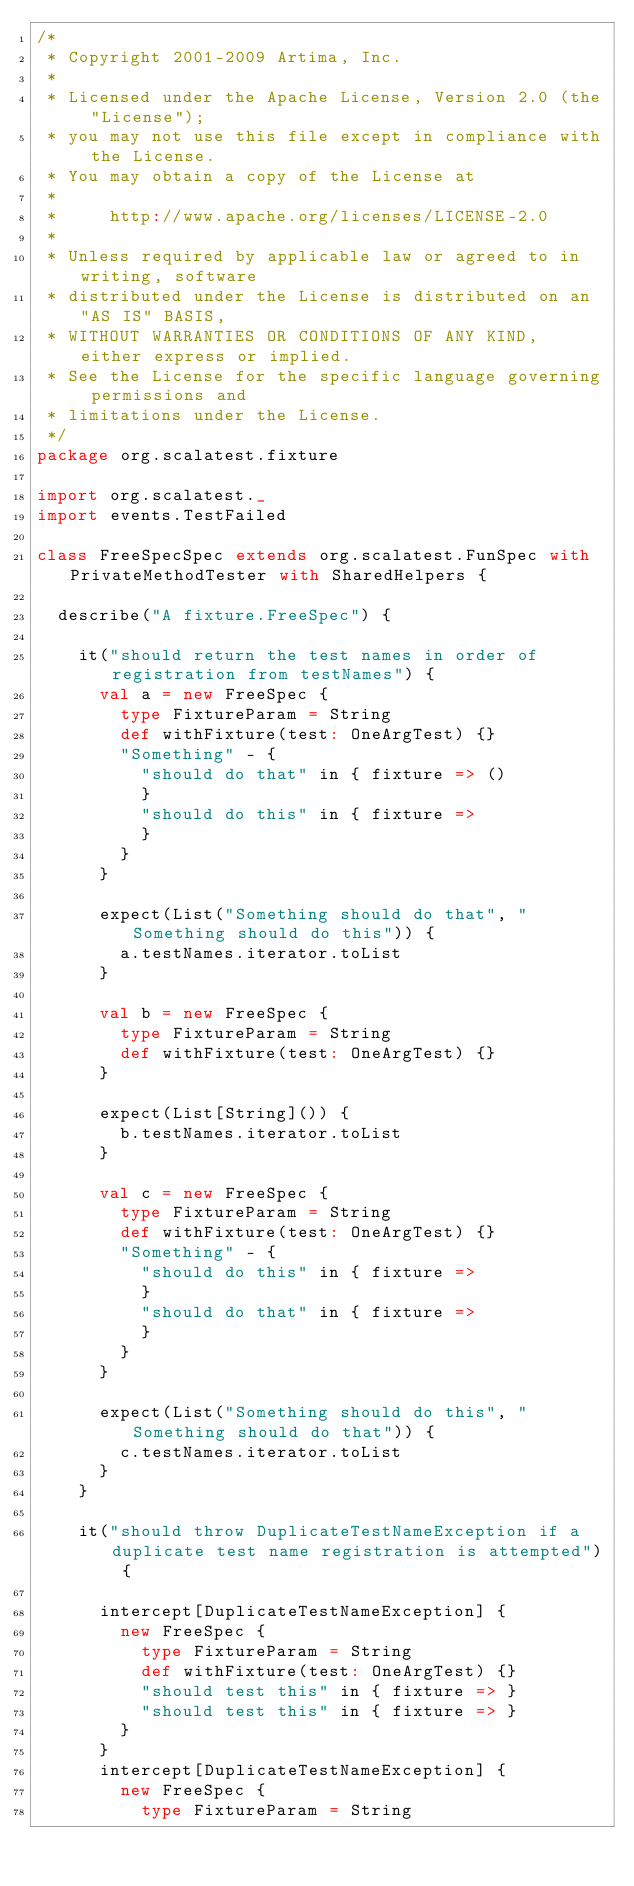<code> <loc_0><loc_0><loc_500><loc_500><_Scala_>/*
 * Copyright 2001-2009 Artima, Inc.
 *
 * Licensed under the Apache License, Version 2.0 (the "License");
 * you may not use this file except in compliance with the License.
 * You may obtain a copy of the License at
 *
 *     http://www.apache.org/licenses/LICENSE-2.0
 *
 * Unless required by applicable law or agreed to in writing, software
 * distributed under the License is distributed on an "AS IS" BASIS,
 * WITHOUT WARRANTIES OR CONDITIONS OF ANY KIND, either express or implied.
 * See the License for the specific language governing permissions and
 * limitations under the License.
 */
package org.scalatest.fixture

import org.scalatest._
import events.TestFailed

class FreeSpecSpec extends org.scalatest.FunSpec with PrivateMethodTester with SharedHelpers {

  describe("A fixture.FreeSpec") {

    it("should return the test names in order of registration from testNames") {
      val a = new FreeSpec {
        type FixtureParam = String
        def withFixture(test: OneArgTest) {}
        "Something" - {
          "should do that" in { fixture => ()
          }
          "should do this" in { fixture =>
          }
        }
      }

      expect(List("Something should do that", "Something should do this")) {
        a.testNames.iterator.toList
      }

      val b = new FreeSpec {
        type FixtureParam = String
        def withFixture(test: OneArgTest) {}
      }

      expect(List[String]()) {
        b.testNames.iterator.toList
      }

      val c = new FreeSpec {
        type FixtureParam = String
        def withFixture(test: OneArgTest) {}
        "Something" - {
          "should do this" in { fixture =>
          }
          "should do that" in { fixture =>
          }
        }
      }

      expect(List("Something should do this", "Something should do that")) {
        c.testNames.iterator.toList
      }
    }

    it("should throw DuplicateTestNameException if a duplicate test name registration is attempted") {

      intercept[DuplicateTestNameException] {
        new FreeSpec {
          type FixtureParam = String
          def withFixture(test: OneArgTest) {}
          "should test this" in { fixture => }
          "should test this" in { fixture => }
        }
      }
      intercept[DuplicateTestNameException] {
        new FreeSpec {
          type FixtureParam = String</code> 